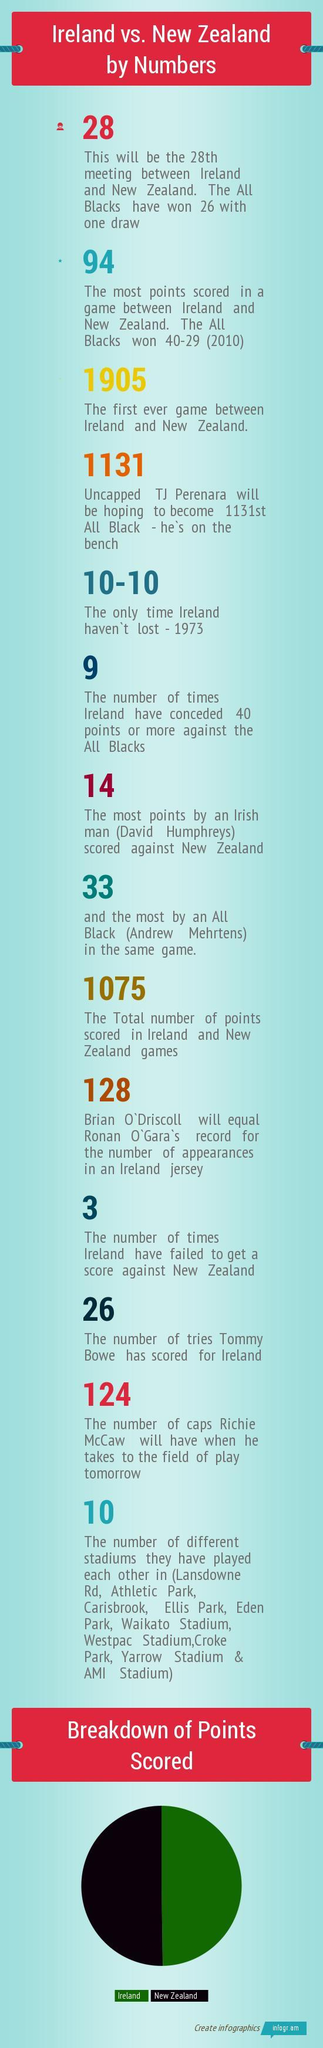Which team does Brian O'Driscoll belong to
Answer the question with a short phrase. Ireland Which stadium names have Park in it other than Croke Park Athletic Park, Ellis Park, Eden Park How much did the All Blacks score in 2010 40 What was the score in 1973 10-10 Which country did David Humphrey belong to Ireland How many have The All Blacks lost 1 Which year was the match a draw 1973 